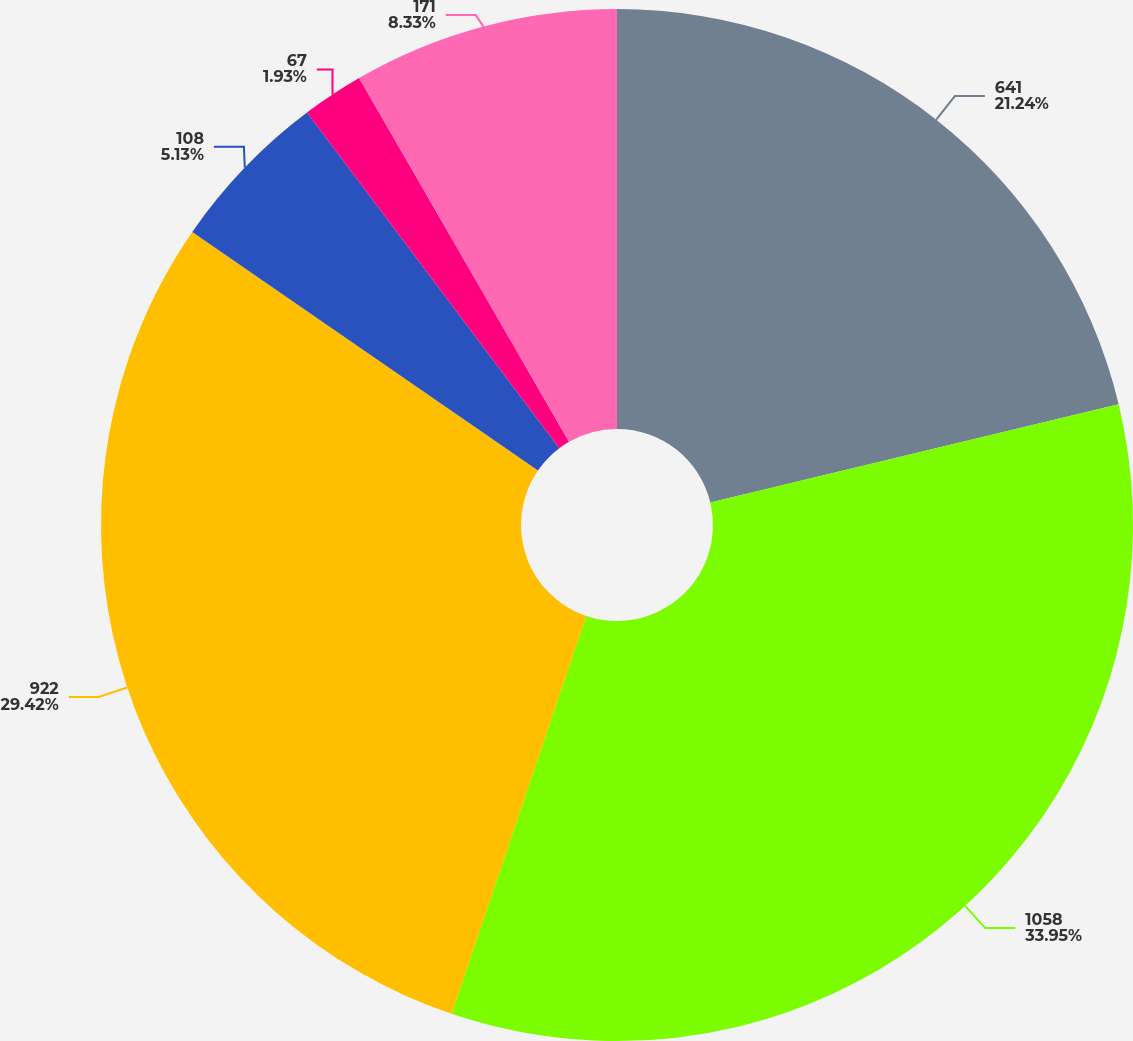Convert chart to OTSL. <chart><loc_0><loc_0><loc_500><loc_500><pie_chart><fcel>641<fcel>1058<fcel>922<fcel>108<fcel>67<fcel>171<nl><fcel>21.24%<fcel>33.96%<fcel>29.42%<fcel>5.13%<fcel>1.93%<fcel>8.33%<nl></chart> 